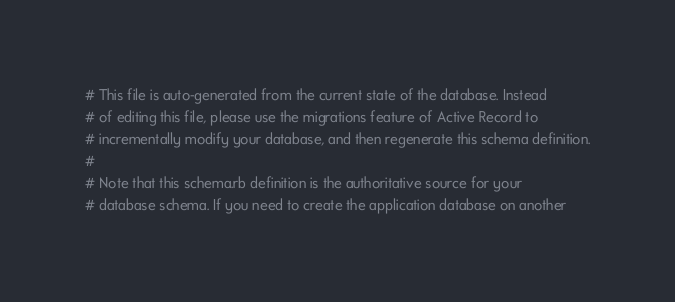<code> <loc_0><loc_0><loc_500><loc_500><_Ruby_># This file is auto-generated from the current state of the database. Instead
# of editing this file, please use the migrations feature of Active Record to
# incrementally modify your database, and then regenerate this schema definition.
#
# Note that this schema.rb definition is the authoritative source for your
# database schema. If you need to create the application database on another</code> 